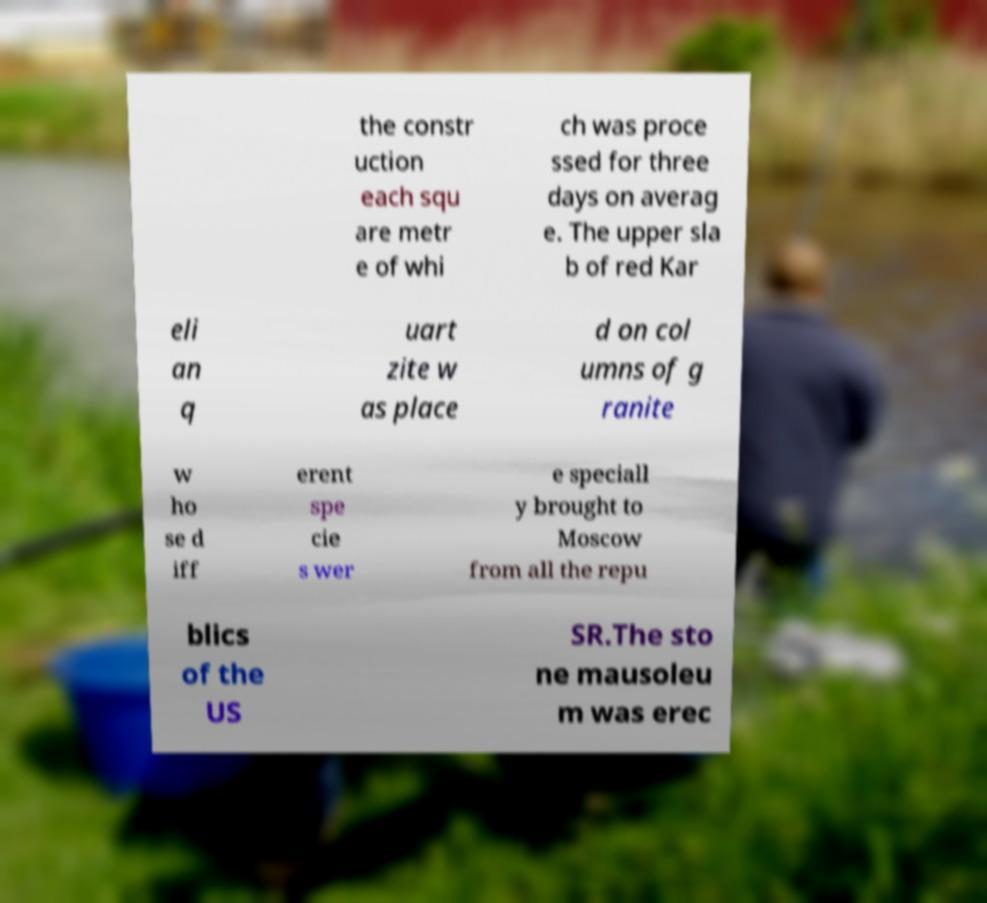Please identify and transcribe the text found in this image. the constr uction each squ are metr e of whi ch was proce ssed for three days on averag e. The upper sla b of red Kar eli an q uart zite w as place d on col umns of g ranite w ho se d iff erent spe cie s wer e speciall y brought to Moscow from all the repu blics of the US SR.The sto ne mausoleu m was erec 